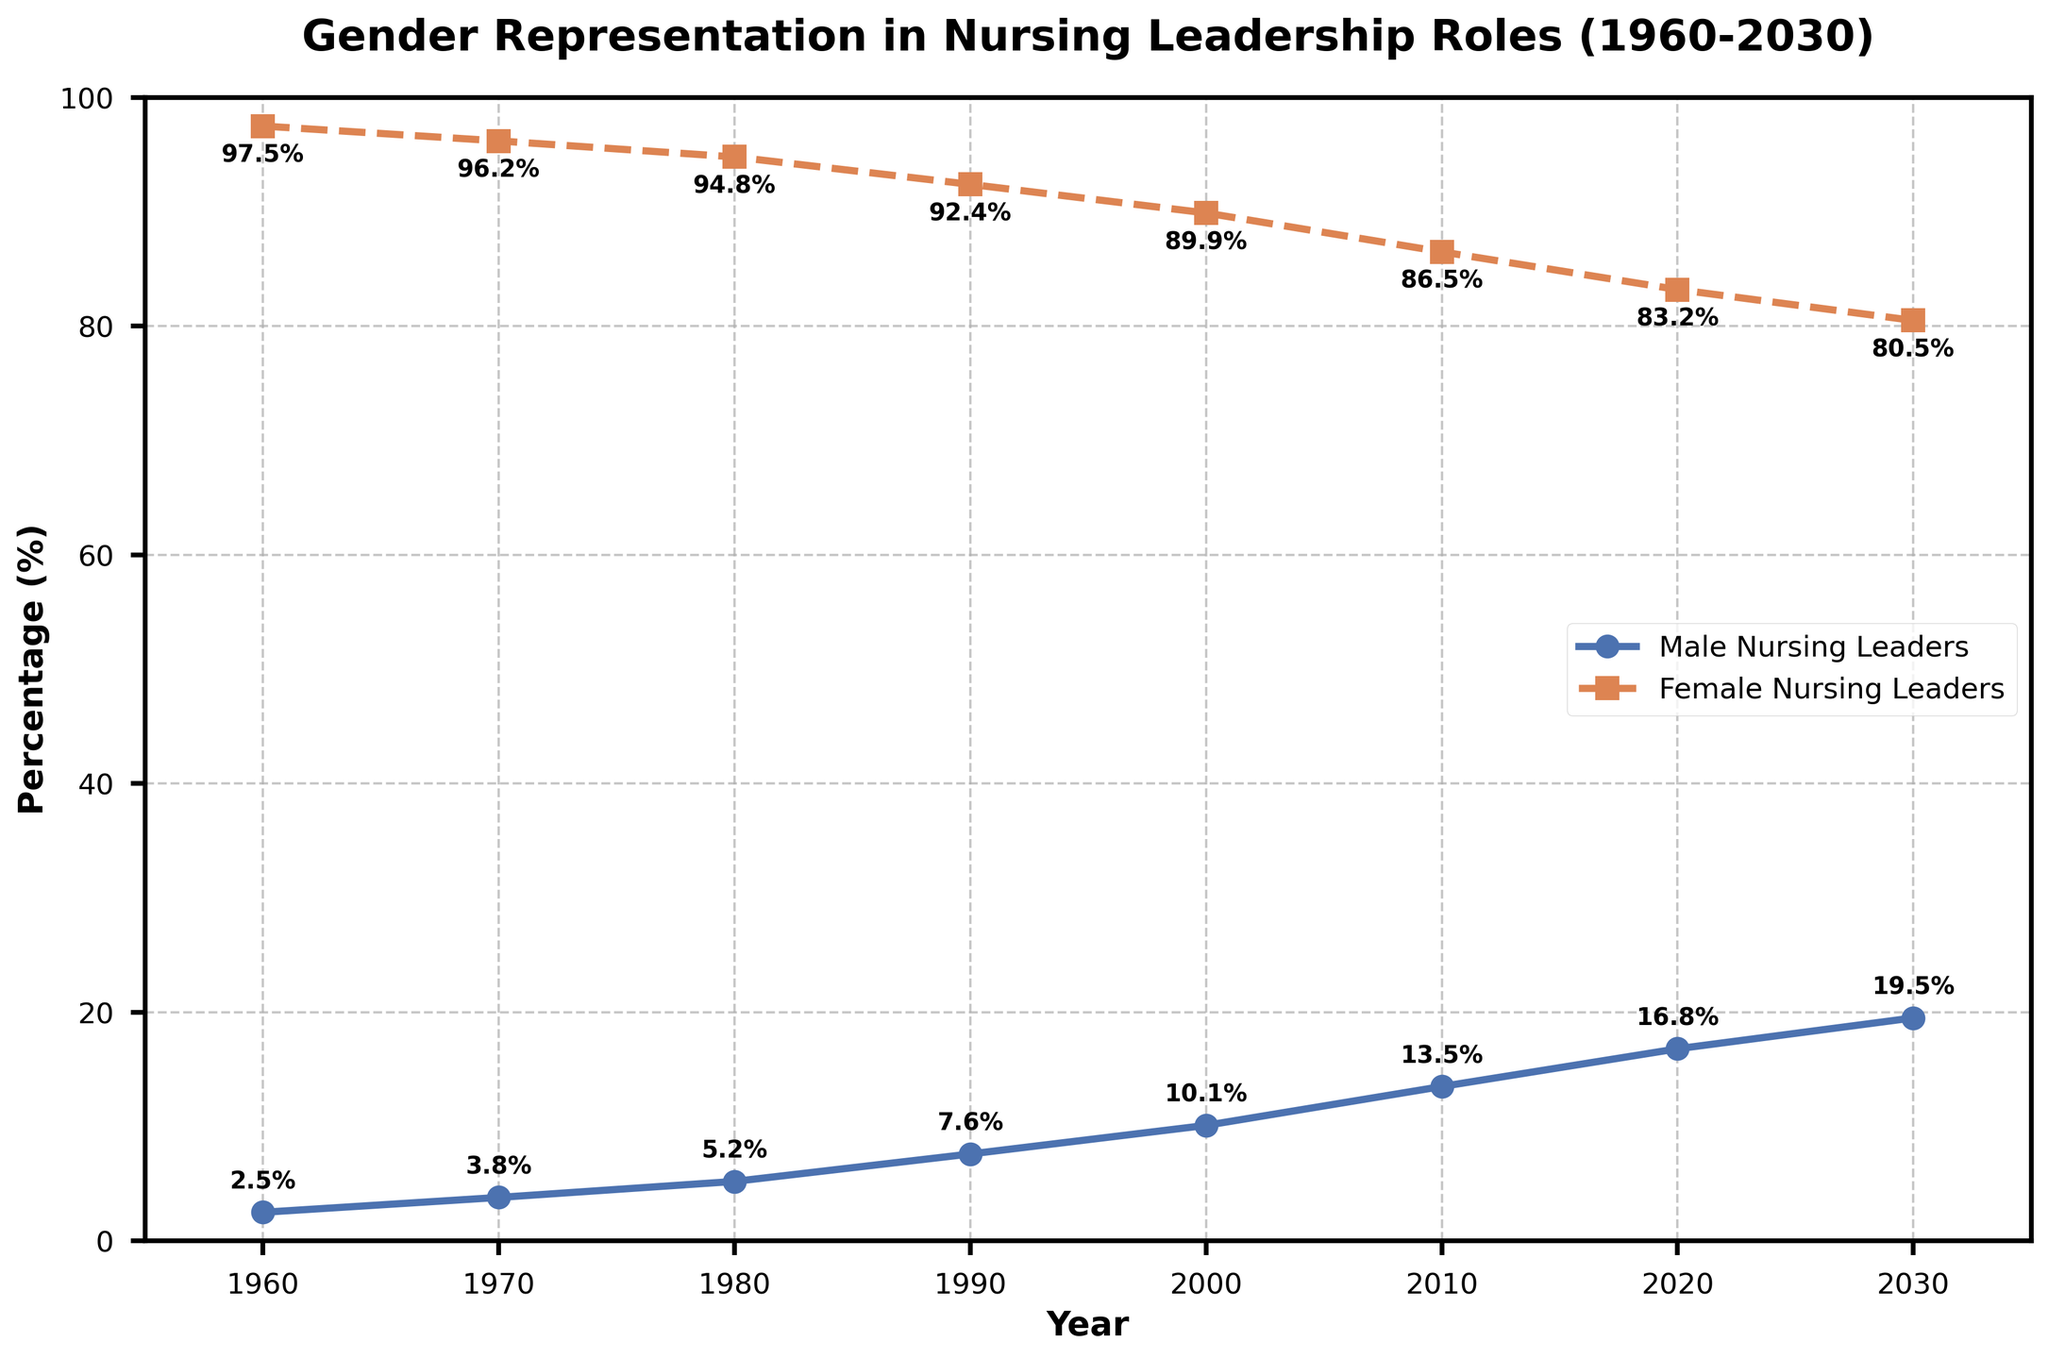What year did male nursing leaders first exceed 10%? To determine this, look at the "Male Nursing Leaders (%)" line and identify the first year when the value exceeds 10%. In this case, it happens in the year 2000.
Answer: 2000 During which decade was the increase in female nursing leaders the highest? Calculate the differences between the percentages of "Female Nursing Leaders (%)" for each decade (i.e., between 1960-1970, 1970-1980, etc.). The differences are:
1970: 96.2 - 97.5 = -1.3
1980: 94.8 - 96.2 = -1.4
1990: 92.4 - 94.8 = -2.4
2000: 89.9 - 92.4 = -2.5
2010: 86.5 - 89.9 = -3.4
2020: 83.2 - 86.5 = -3.3
The period of 1960-1970 shows the lowest decrease, an increase in the proportion of female leaders.
Answer: 1960-1970 In what year did the gap between male and female nursing leaders narrow the most? Calculate the gap between the percentages of male and female nursing leaders for each year. Identify the year where the largest narrowing occurs. (This examines the percentage difference year-over-year.) The narrowing happens the most between:
1990-2000 (7.6%-10.1% vs. 92.4%-89.9%) difference narrows by 2.6% compared to 1.4% to 1.7% in other years.
Answer: 2000 Which group had a consistent trend of increasing or decreasing percentages between 1960 and 2030? Observe the patterns of both "Male Nursing Leaders (%)" and "Female Nursing Leaders (%)" lines. "Male Nursing Leaders (%)" shows a consistent increase and "Female Nursing Leaders (%)" shows a consistent decrease over the years.
Answer: Male Nursing Leaders increasing, Female Nursing Leaders decreasing What's the average representation percentage of female nursing leaders across all years represented in the chart? Sum up the percentages of female nursing leaders for each shown year and divide by the number of years. (97.5 + 96.2 + 94.8 + 92.4 + 89.9 + 86.5 + 83.2 + 80.5)/8 = 90.1%.
Answer: 90.1% In which decade did female nursing leaders have a higher than 90% representation? Visualize the percentage of female nursing leaders in each decade (i.e., 1960s, 1970s, 1980s, 1990s). Notice they were above 90% before the 2000s.
Answer: Before 2000 How has male representation changed from 1960 to 2030? Identify the percentage of "Male Nursing Leaders (%)" in 1960 and compare it with the percentage in 2030. 1960: 2.5% → 2030: 19.5%. Therefore, male representation has increased by 17%.
Answer: Increased by 17% In what year do male and female nursing leaders have the closest values? Observe the plotted lines to identify which year the gap between male and female nursing leaders is the smallest. The closest values are in 2030 with 19.5% male and 80.5% female, gap of 61%.
Answer: 2030 